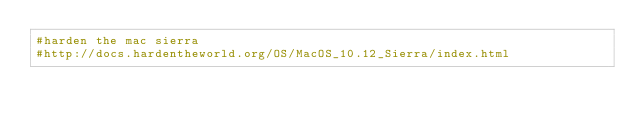Convert code to text. <code><loc_0><loc_0><loc_500><loc_500><_Bash_>#harden the mac sierra
#http://docs.hardentheworld.org/OS/MacOS_10.12_Sierra/index.html
</code> 